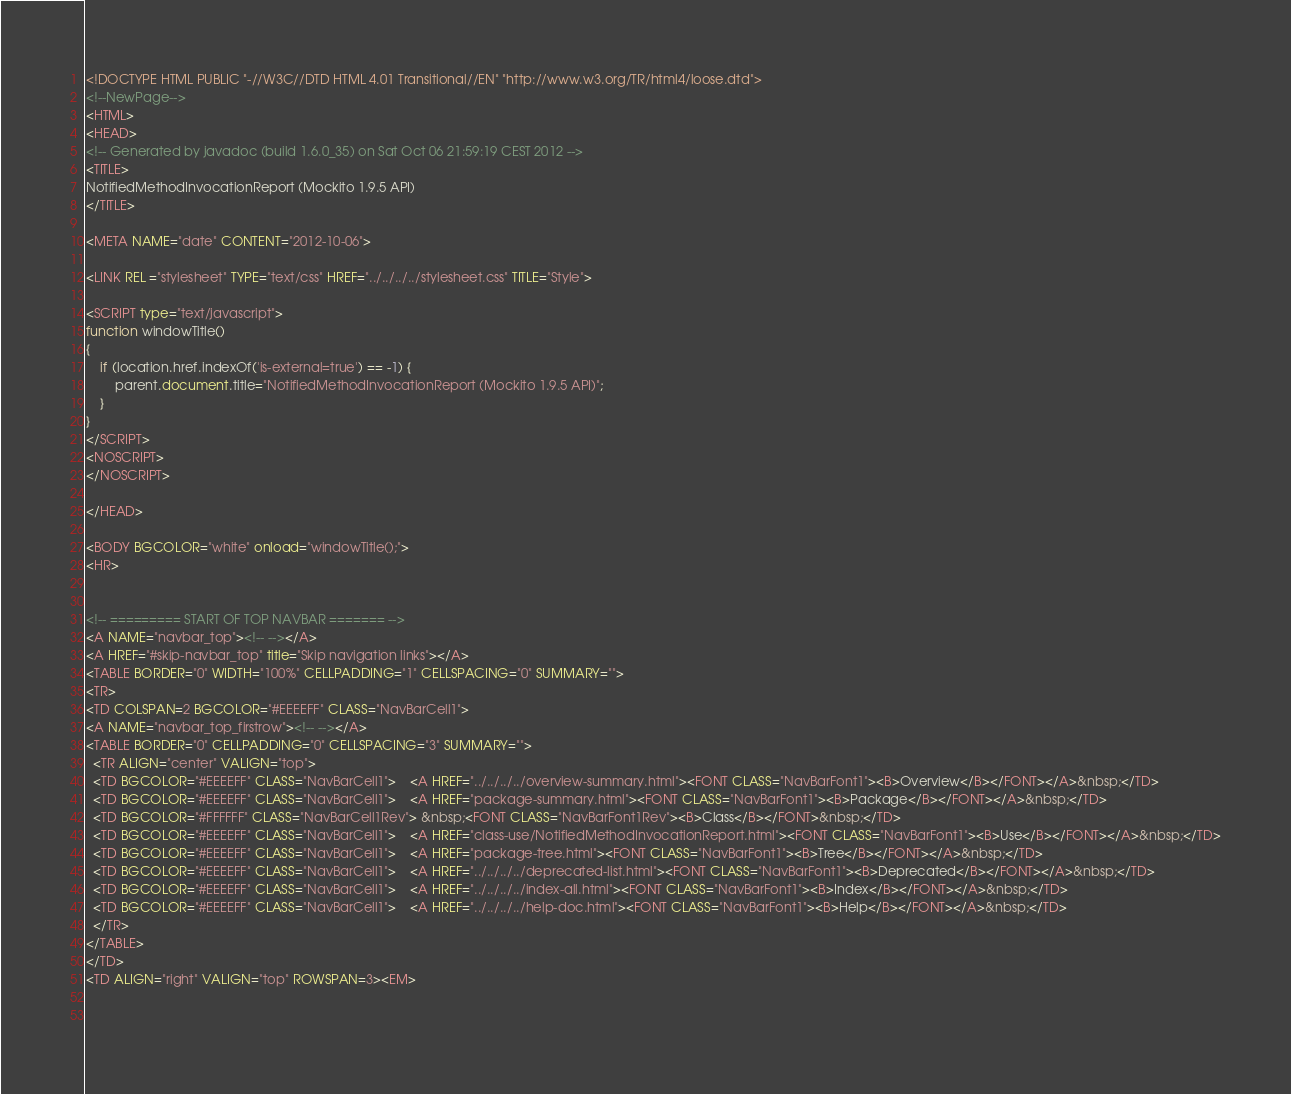<code> <loc_0><loc_0><loc_500><loc_500><_HTML_><!DOCTYPE HTML PUBLIC "-//W3C//DTD HTML 4.01 Transitional//EN" "http://www.w3.org/TR/html4/loose.dtd">
<!--NewPage-->
<HTML>
<HEAD>
<!-- Generated by javadoc (build 1.6.0_35) on Sat Oct 06 21:59:19 CEST 2012 -->
<TITLE>
NotifiedMethodInvocationReport (Mockito 1.9.5 API)
</TITLE>

<META NAME="date" CONTENT="2012-10-06">

<LINK REL ="stylesheet" TYPE="text/css" HREF="../../../../stylesheet.css" TITLE="Style">

<SCRIPT type="text/javascript">
function windowTitle()
{
    if (location.href.indexOf('is-external=true') == -1) {
        parent.document.title="NotifiedMethodInvocationReport (Mockito 1.9.5 API)";
    }
}
</SCRIPT>
<NOSCRIPT>
</NOSCRIPT>

</HEAD>

<BODY BGCOLOR="white" onload="windowTitle();">
<HR>


<!-- ========= START OF TOP NAVBAR ======= -->
<A NAME="navbar_top"><!-- --></A>
<A HREF="#skip-navbar_top" title="Skip navigation links"></A>
<TABLE BORDER="0" WIDTH="100%" CELLPADDING="1" CELLSPACING="0" SUMMARY="">
<TR>
<TD COLSPAN=2 BGCOLOR="#EEEEFF" CLASS="NavBarCell1">
<A NAME="navbar_top_firstrow"><!-- --></A>
<TABLE BORDER="0" CELLPADDING="0" CELLSPACING="3" SUMMARY="">
  <TR ALIGN="center" VALIGN="top">
  <TD BGCOLOR="#EEEEFF" CLASS="NavBarCell1">    <A HREF="../../../../overview-summary.html"><FONT CLASS="NavBarFont1"><B>Overview</B></FONT></A>&nbsp;</TD>
  <TD BGCOLOR="#EEEEFF" CLASS="NavBarCell1">    <A HREF="package-summary.html"><FONT CLASS="NavBarFont1"><B>Package</B></FONT></A>&nbsp;</TD>
  <TD BGCOLOR="#FFFFFF" CLASS="NavBarCell1Rev"> &nbsp;<FONT CLASS="NavBarFont1Rev"><B>Class</B></FONT>&nbsp;</TD>
  <TD BGCOLOR="#EEEEFF" CLASS="NavBarCell1">    <A HREF="class-use/NotifiedMethodInvocationReport.html"><FONT CLASS="NavBarFont1"><B>Use</B></FONT></A>&nbsp;</TD>
  <TD BGCOLOR="#EEEEFF" CLASS="NavBarCell1">    <A HREF="package-tree.html"><FONT CLASS="NavBarFont1"><B>Tree</B></FONT></A>&nbsp;</TD>
  <TD BGCOLOR="#EEEEFF" CLASS="NavBarCell1">    <A HREF="../../../../deprecated-list.html"><FONT CLASS="NavBarFont1"><B>Deprecated</B></FONT></A>&nbsp;</TD>
  <TD BGCOLOR="#EEEEFF" CLASS="NavBarCell1">    <A HREF="../../../../index-all.html"><FONT CLASS="NavBarFont1"><B>Index</B></FONT></A>&nbsp;</TD>
  <TD BGCOLOR="#EEEEFF" CLASS="NavBarCell1">    <A HREF="../../../../help-doc.html"><FONT CLASS="NavBarFont1"><B>Help</B></FONT></A>&nbsp;</TD>
  </TR>
</TABLE>
</TD>
<TD ALIGN="right" VALIGN="top" ROWSPAN=3><EM>

        </code> 